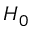<formula> <loc_0><loc_0><loc_500><loc_500>H _ { 0 }</formula> 